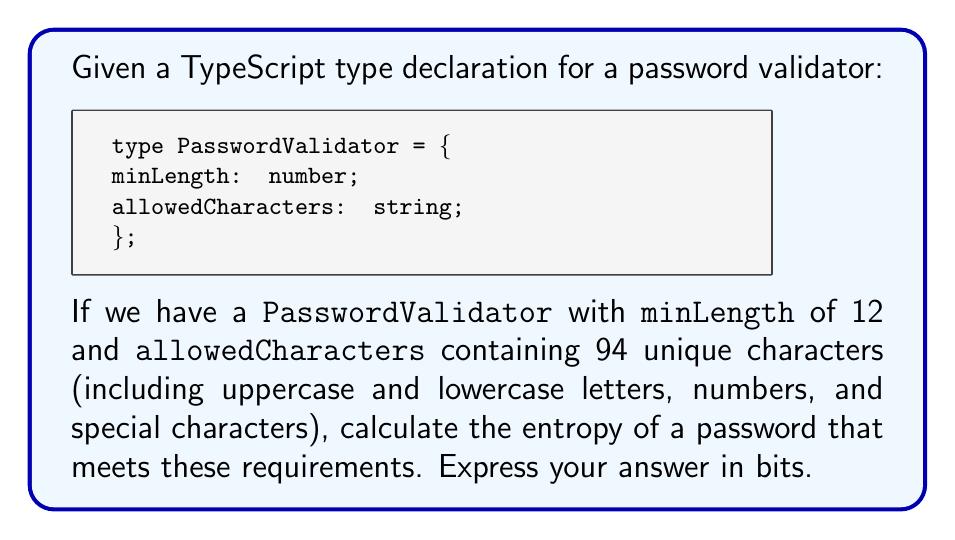Could you help me with this problem? To calculate the password entropy, we'll follow these steps:

1. Understand the concept:
   Password entropy is a measure of how unpredictable a password is. It's calculated using the formula:

   $$E = L \log_2(R)$$

   Where:
   $E$ = entropy in bits
   $L$ = length of the password
   $R$ = size of the character set (number of possible characters)

2. Identify the variables:
   $L = 12$ (minimum length of the password)
   $R = 94$ (number of allowed characters)

3. Apply the formula:
   $$E = 12 \log_2(94)$$

4. Calculate the logarithm:
   $$\log_2(94) \approx 6.55459$$

5. Multiply by the length:
   $$E = 12 * 6.55459 \approx 78.65508$$

6. Round to two decimal places:
   $$E \approx 78.66 \text{ bits}$$

This calculation represents the entropy of a 12-character password using a character set of 94 unique characters.
Answer: 78.66 bits 